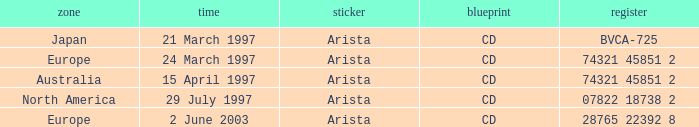What Label has the Region of Australia? Arista. 